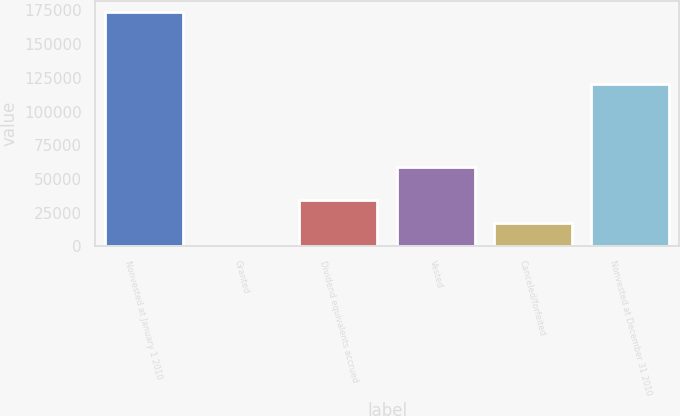Convert chart. <chart><loc_0><loc_0><loc_500><loc_500><bar_chart><fcel>Nonvested at January 1 2010<fcel>Granted<fcel>Dividend equivalents accrued<fcel>Vested<fcel>Canceled/forfeited<fcel>Nonvested at December 31 2010<nl><fcel>173502<fcel>4.24<fcel>34703.8<fcel>58808<fcel>17354<fcel>120237<nl></chart> 